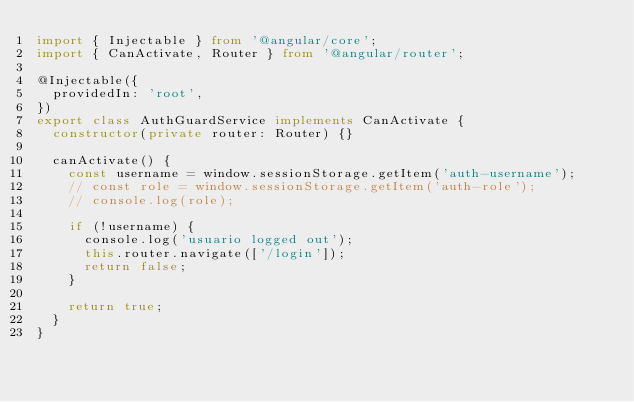Convert code to text. <code><loc_0><loc_0><loc_500><loc_500><_TypeScript_>import { Injectable } from '@angular/core';
import { CanActivate, Router } from '@angular/router';

@Injectable({
  providedIn: 'root',
})
export class AuthGuardService implements CanActivate {
  constructor(private router: Router) {}

  canActivate() {
    const username = window.sessionStorage.getItem('auth-username');
    // const role = window.sessionStorage.getItem('auth-role');
    // console.log(role);

    if (!username) {
      console.log('usuario logged out');
      this.router.navigate(['/login']);
      return false;
    }

    return true;
  }
}
</code> 